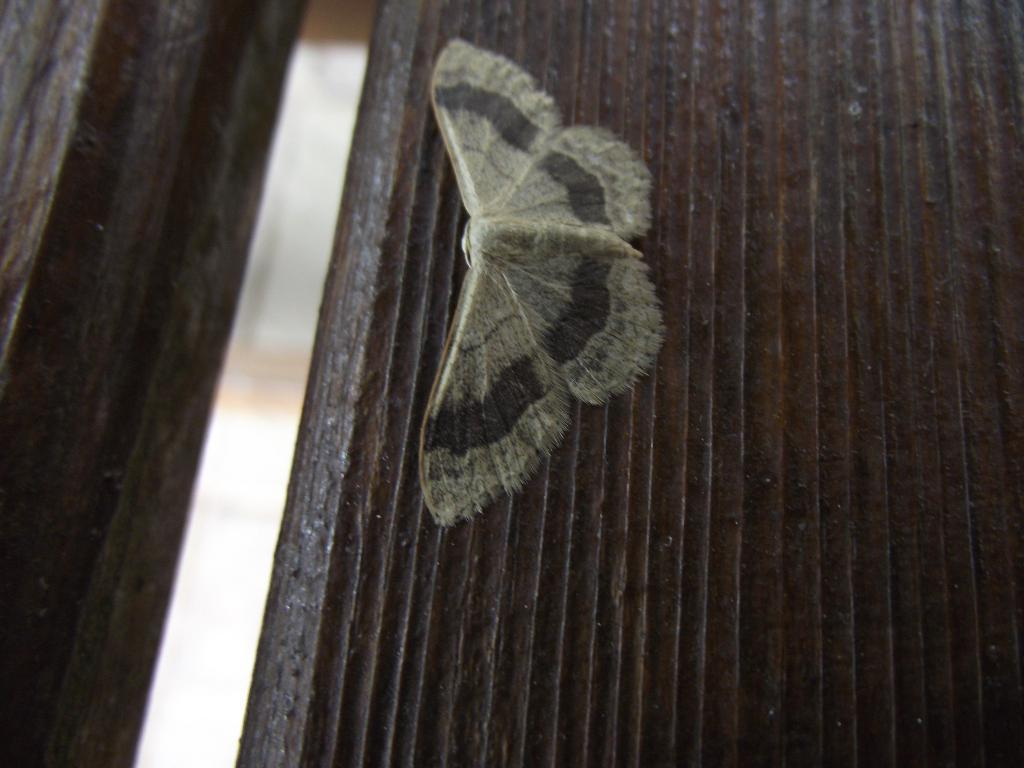What type of creature is present in the image? There is an insect in the image. What colors can be seen on the insect? The insect has grey and black colors. What is the color of the background in the image? The background of the image is black. What type of form can be seen on the notebook in the image? There is no notebook present in the image; it only features an insect with grey and black colors against a black background. 